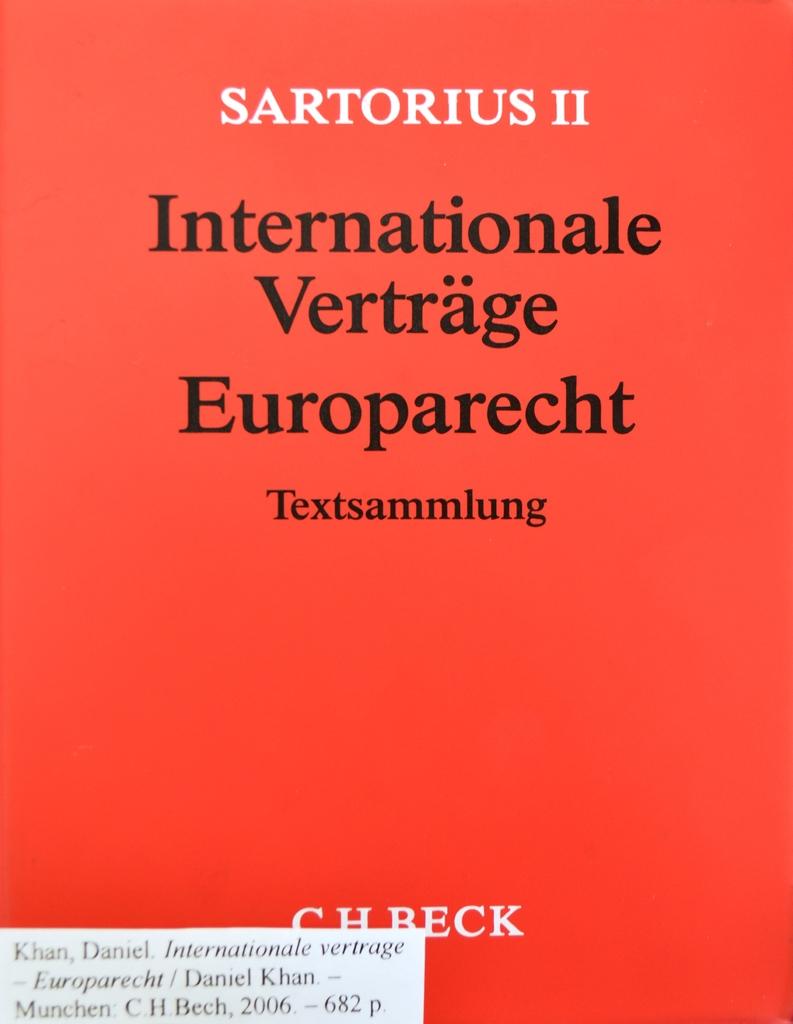What is the name of the book?
Offer a very short reply. Internationale vertrage europarecht. 